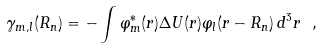Convert formula to latex. <formula><loc_0><loc_0><loc_500><loc_500>\gamma _ { m , l } ( { R _ { n } } ) = - \int \varphi _ { m } ^ { * } ( { r } ) \Delta U ( { r } ) \varphi _ { l } ( { r - R _ { n } } ) \, d ^ { 3 } r \ ,</formula> 